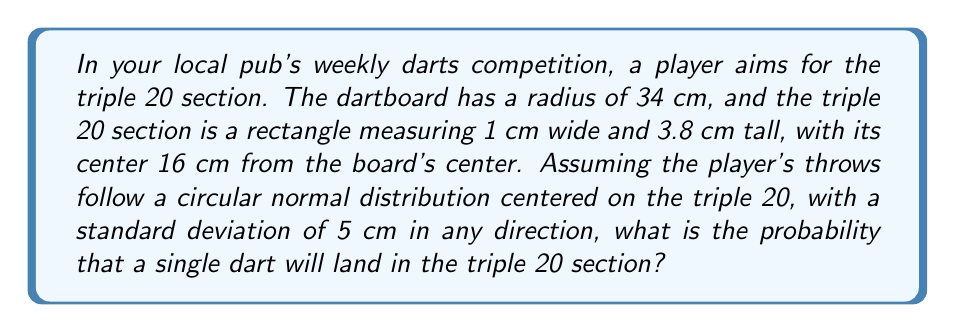Can you answer this question? To solve this problem, we need to use the properties of the circular normal distribution and integrate over the area of the triple 20 section. Let's break it down step by step:

1) The probability density function for a circular normal distribution with standard deviation $\sigma$ is:

   $$f(x,y) = \frac{1}{2\pi\sigma^2} e^{-\frac{x^2+y^2}{2\sigma^2}}$$

2) We need to integrate this function over the area of the triple 20 section. However, the integration is complex due to the rotated coordinates.

3) Instead, we can use the cumulative distribution function of the normal distribution to simplify our calculation. The probability of landing within a small rectangle can be approximated as:

   $$P(rectangle) \approx (CDF(x_2) - CDF(x_1)) \cdot (CDF(y_2) - CDF(y_1))$$

   where $CDF$ is the cumulative distribution function of the standard normal distribution.

4) The center of the triple 20 is 16 cm from the board's center. The section is 1 cm wide and 3.8 cm tall. So, in the coordinate system centered on the triple 20:

   $x_1 = -0.5$ cm, $x_2 = 0.5$ cm
   $y_1 = -1.9$ cm, $y_2 = 1.9$ cm

5) We need to standardize these values by dividing by the standard deviation (5 cm):

   $x_1 = -0.1$, $x_2 = 0.1$
   $y_1 = -0.38$, $y_2 = 0.38$

6) Now we can calculate:

   $$P(triple\,20) \approx (CDF(0.1) - CDF(-0.1)) \cdot (CDF(0.38) - CDF(-0.38))$$

7) Using a standard normal distribution table or calculator:

   $CDF(0.1) - CDF(-0.1) \approx 0.0797$
   $CDF(0.38) - CDF(-0.38) \approx 0.2960$

8) Therefore:

   $$P(triple\,20) \approx 0.0797 \cdot 0.2960 \approx 0.0236$$
Answer: The probability of a single dart landing in the triple 20 section is approximately 0.0236 or 2.36%. 